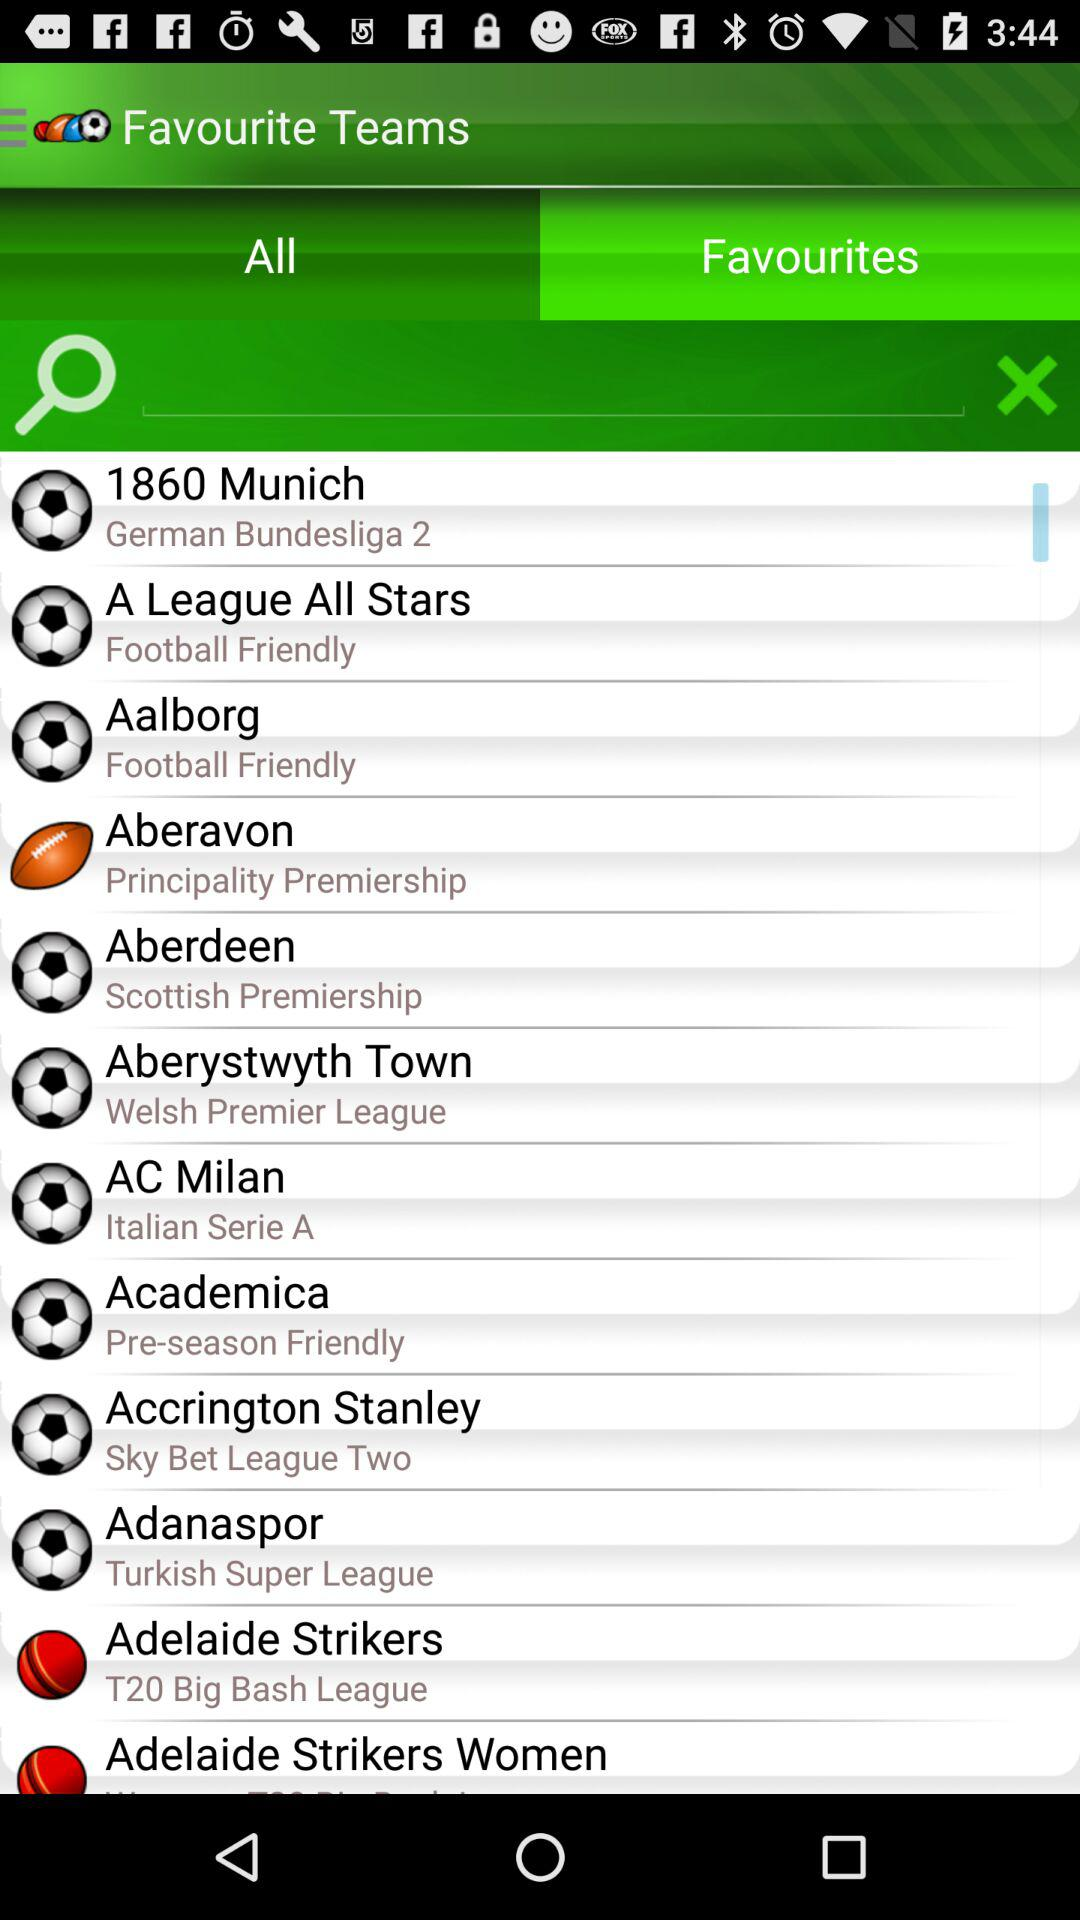Which team will play in "Sky Bet League Two"? The team that will play in "Sky Bet League Two" is "Accrington Stanley". 